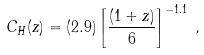Convert formula to latex. <formula><loc_0><loc_0><loc_500><loc_500>C _ { H } ( z ) = ( 2 . 9 ) \left [ \frac { ( 1 + z ) } { 6 } \right ] ^ { - 1 . 1 } \, ,</formula> 